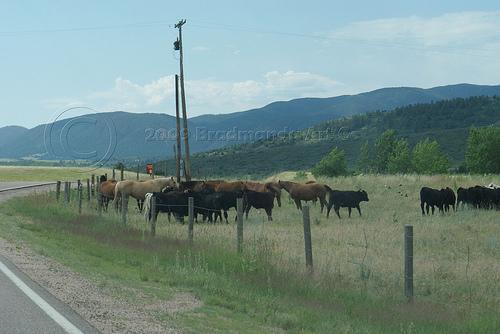How many copyright symbols are shown?
Give a very brief answer. 1. 